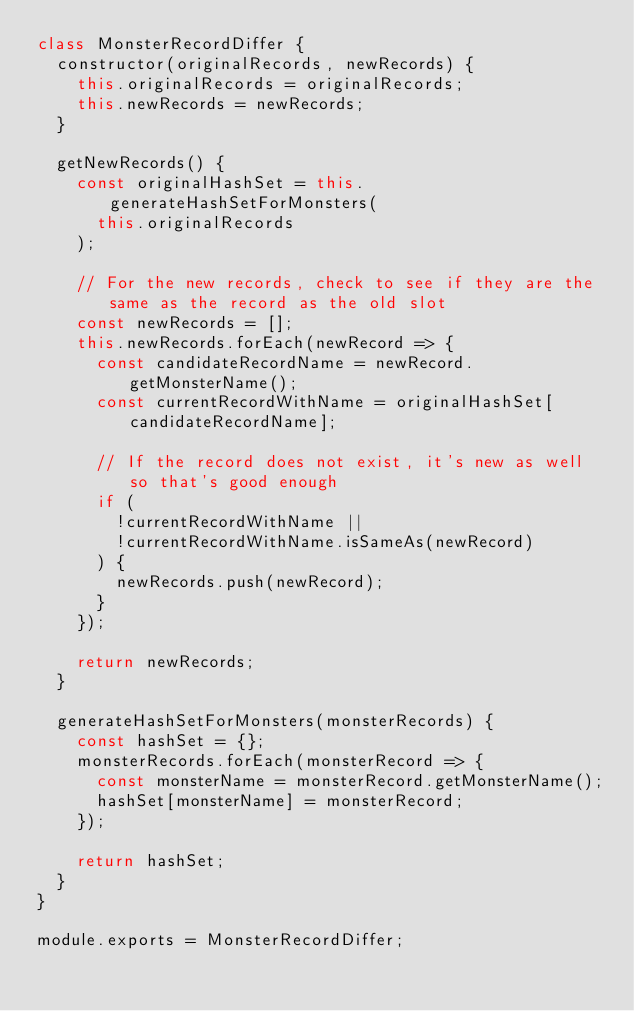<code> <loc_0><loc_0><loc_500><loc_500><_JavaScript_>class MonsterRecordDiffer {
  constructor(originalRecords, newRecords) {
    this.originalRecords = originalRecords;
    this.newRecords = newRecords;
  }

  getNewRecords() {
    const originalHashSet = this.generateHashSetForMonsters(
      this.originalRecords
    );

    // For the new records, check to see if they are the same as the record as the old slot
    const newRecords = [];
    this.newRecords.forEach(newRecord => {
      const candidateRecordName = newRecord.getMonsterName();
      const currentRecordWithName = originalHashSet[candidateRecordName];

      // If the record does not exist, it's new as well so that's good enough
      if (
        !currentRecordWithName ||
        !currentRecordWithName.isSameAs(newRecord)
      ) {
        newRecords.push(newRecord);
      }
    });

    return newRecords;
  }

  generateHashSetForMonsters(monsterRecords) {
    const hashSet = {};
    monsterRecords.forEach(monsterRecord => {
      const monsterName = monsterRecord.getMonsterName();
      hashSet[monsterName] = monsterRecord;
    });

    return hashSet;
  }
}

module.exports = MonsterRecordDiffer;
</code> 